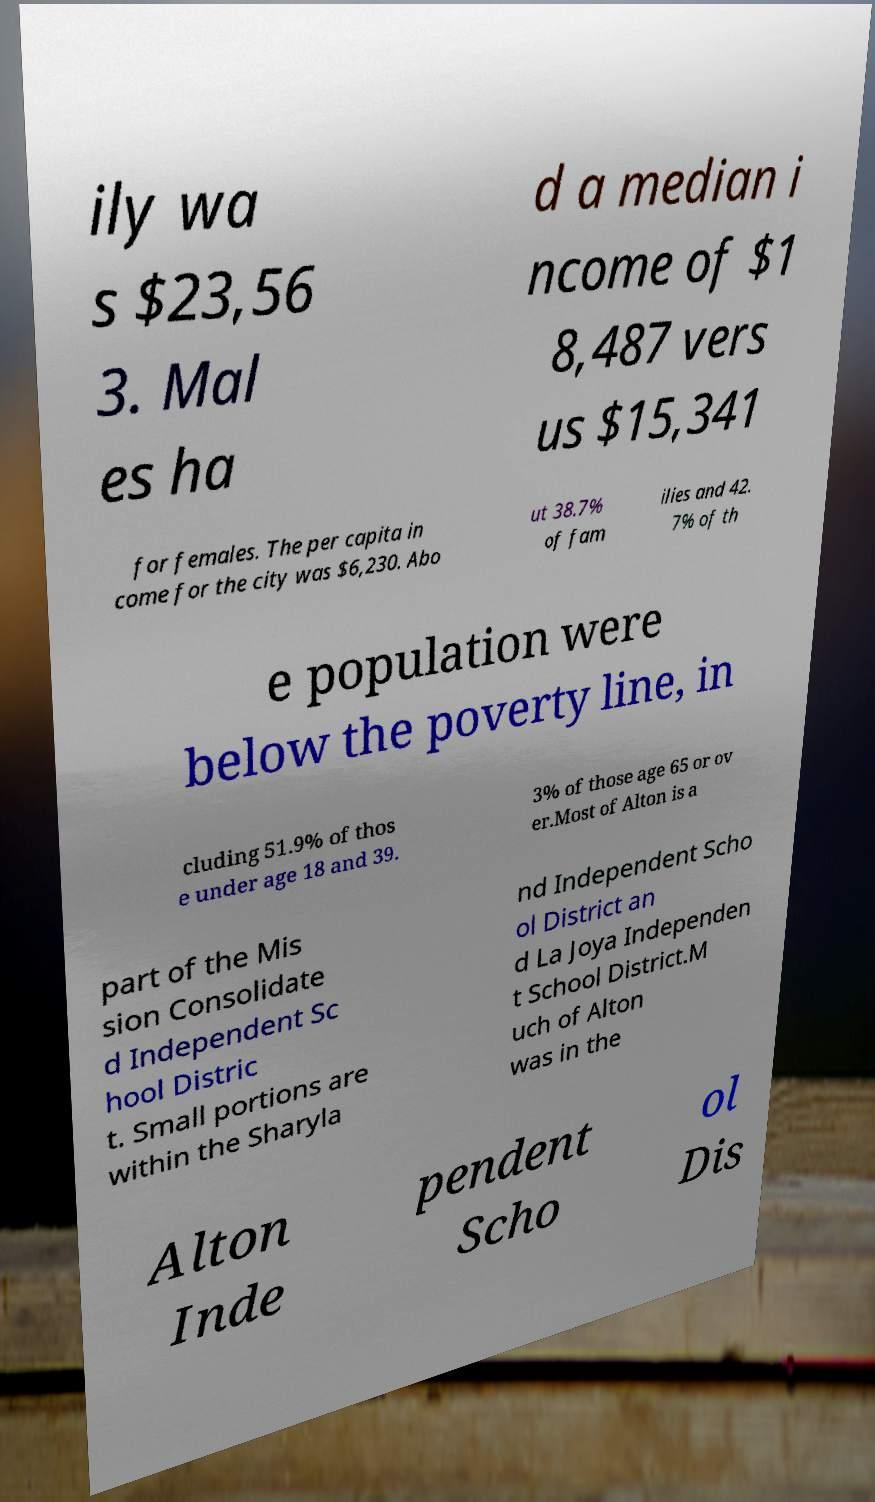There's text embedded in this image that I need extracted. Can you transcribe it verbatim? ily wa s $23,56 3. Mal es ha d a median i ncome of $1 8,487 vers us $15,341 for females. The per capita in come for the city was $6,230. Abo ut 38.7% of fam ilies and 42. 7% of th e population were below the poverty line, in cluding 51.9% of thos e under age 18 and 39. 3% of those age 65 or ov er.Most of Alton is a part of the Mis sion Consolidate d Independent Sc hool Distric t. Small portions are within the Sharyla nd Independent Scho ol District an d La Joya Independen t School District.M uch of Alton was in the Alton Inde pendent Scho ol Dis 